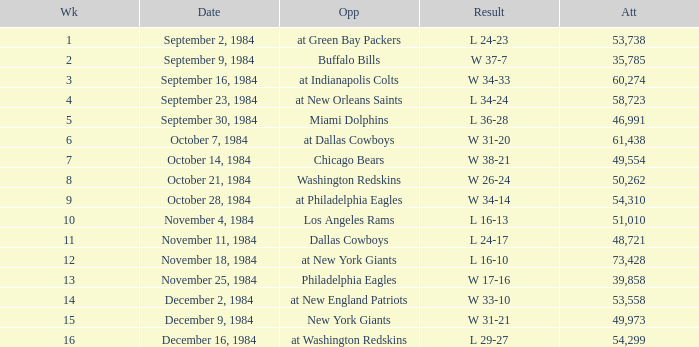What is the sum of attendance when the result was l 16-13? 51010.0. 